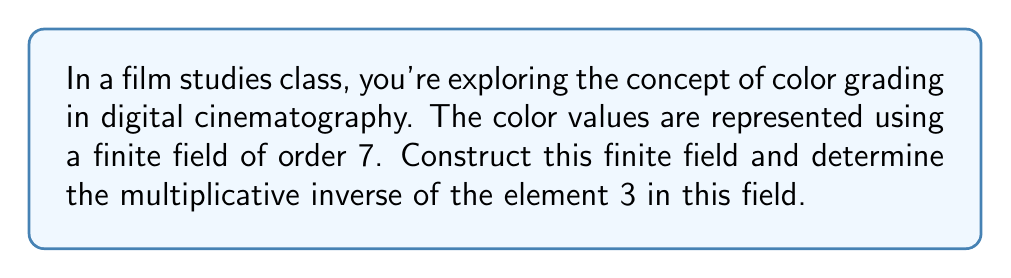Could you help me with this problem? To solve this problem, we'll follow these steps:

1) Construct the finite field of order 7:
   The finite field of order 7 is simply the integers modulo 7, denoted as $\mathbb{F}_7$ or $\mathbb{Z}_7$.
   The elements of this field are: $\{0, 1, 2, 3, 4, 5, 6\}$

2) Addition and multiplication in this field are performed modulo 7.

3) To find the multiplicative inverse of 3, we need to find a number $x$ such that:
   $3x \equiv 1 \pmod{7}$

4) We can solve this by trying each element:
   $3 \cdot 1 \equiv 3 \pmod{7}$
   $3 \cdot 2 \equiv 6 \pmod{7}$
   $3 \cdot 3 \equiv 2 \pmod{7}$
   $3 \cdot 4 \equiv 5 \pmod{7}$
   $3 \cdot 5 \equiv 1 \pmod{7}$

5) We've found that $3 \cdot 5 \equiv 1 \pmod{7}$, so 5 is the multiplicative inverse of 3 in $\mathbb{F}_7$.

This can be verified:
$3 \cdot 5 = 15 \equiv 1 \pmod{7}$

Therefore, in the finite field of order 7, which could represent the color values in digital cinematography, the multiplicative inverse of 3 is 5.
Answer: 5 